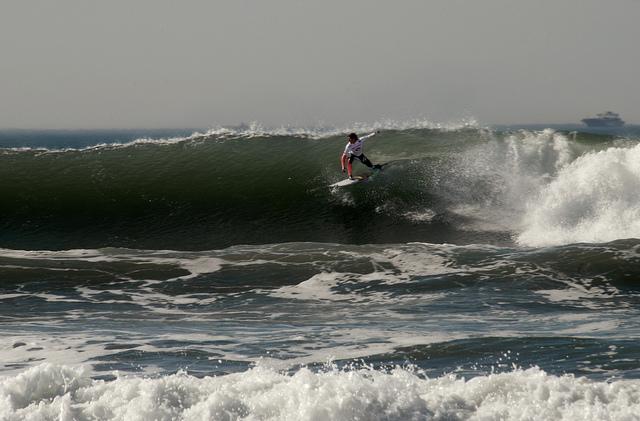How many people in the water?
Answer briefly. 1. What is this person doing?
Concise answer only. Surfing. What does the weather appear to be?
Concise answer only. Sunny. What sport is the man doing?
Quick response, please. Surfing. What color are the waves?
Short answer required. Green. Who is in the water?
Answer briefly. Surfer. What position is the man in?
Give a very brief answer. Standing. 